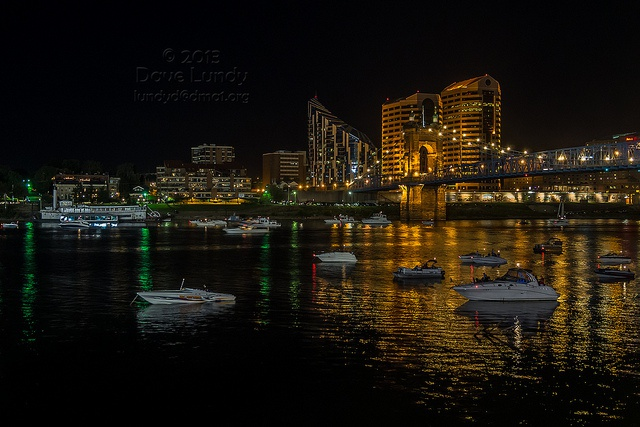Describe the objects in this image and their specific colors. I can see boat in black, maroon, gray, and olive tones, boat in black, gray, and maroon tones, boat in black, gray, and purple tones, boat in black, gray, and maroon tones, and boat in black, gray, and maroon tones in this image. 